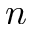<formula> <loc_0><loc_0><loc_500><loc_500>n</formula> 